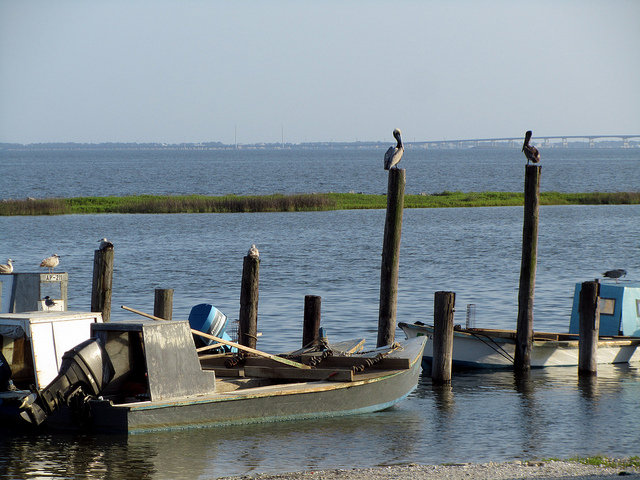<image>Which boat is moving? There is no boat moving in the image. Which boat is moving? There is no boat that is moving in the image. 